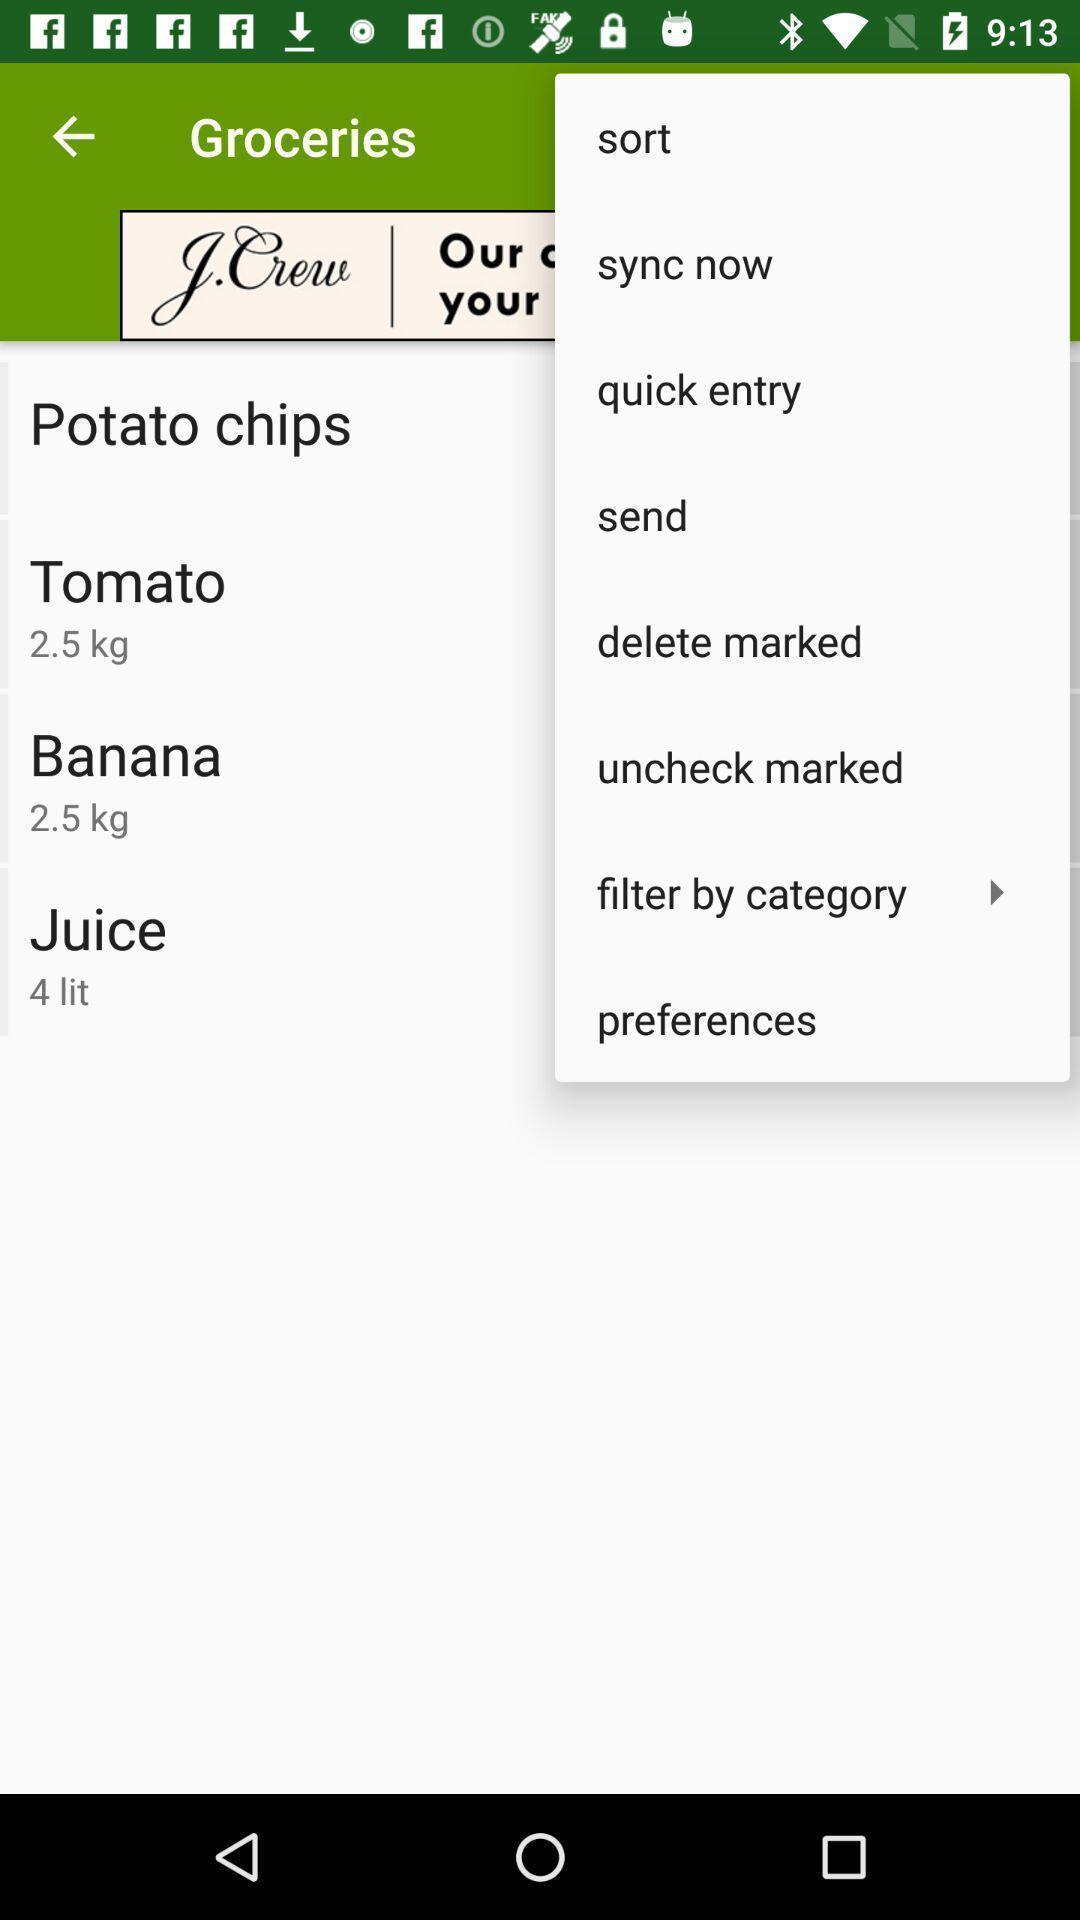Provide a description of this screenshot. Push up notification displayed various options. 